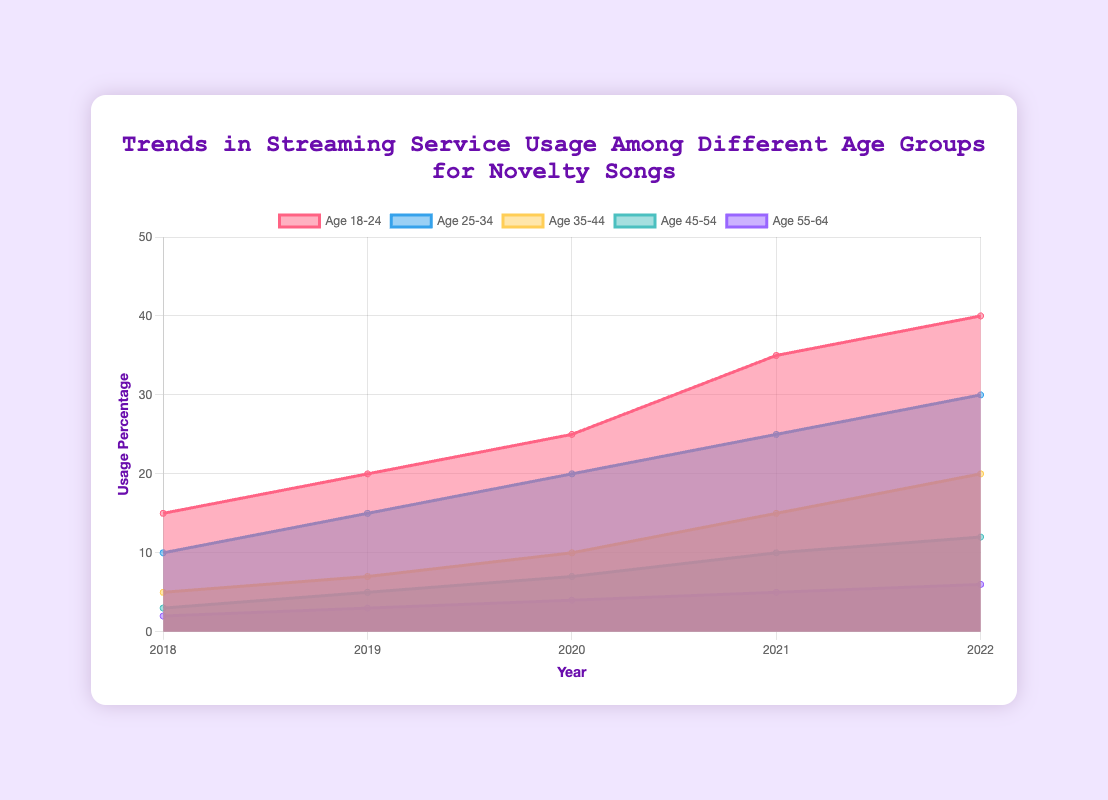Which age group shows the highest streaming service usage in 2022? By examining the data, we see that the Age 18-24 group has the highest value in 2022 at 40%.
Answer: Age 18-24 How has the streaming service usage percentage for the Age 25-34 group changed from 2018 to 2022? In 2018, the Age 25-34 group's usage was 10%. By 2022, it increased to 30%, so the change is 30% - 10% = 20%.
Answer: Increased by 20% What is the overall trend for the Age 45-54 group's streaming service usage over the years? The data shows an increasing trend from 3% in 2018 to 12% in 2022.
Answer: Increasing Which two age groups had the smallest and the largest usage growth from 2018 to 2022, respectively? The Age 18-24 group grew from 15% to 40%, whereas the Age 55-64 group grew from 2% to 6%. The largest growth is 40% - 15% = 25%, and the smallest is 6% - 2% = 4%.
Answer: Largest: Age 18-24, Smallest: Age 55-64 Compare the streaming service usage in 2020 between Age 18-24 and Age 35-44 groups. In 2020, Age 18-24 had 25%, and Age 35-44 had 10%. Therefore, Age 18-24 is higher by 25% - 10% = 15%.
Answer: Age 18-24 is 15% higher Across all age groups, what is the average streaming service usage in 2021? Summing the values for 2021: 35% (18-24) + 25% (25-34) + 15% (35-44) + 10% (45-54) + 5% (55-64) = 90%. Dividing by 5, we get an average of 90% / 5 = 18%.
Answer: 18% By how much did the streaming service usage for the Age 18-24 group increase from 2019 to 2021? From 2019's 20% to 2021's 35%, the increase is 35% - 20% = 15%.
Answer: 15% Is there any year where the Age 25-34 group's usage is higher than the Age 18-24 group's usage? For each year from 2018 to 2022, Age 18-24's usage is consistently higher than Age 25-34's usage.
Answer: No What year did the Age 35-44 group cross the 10% threshold in streaming service usage? The data shows that the Age 35-44 group crossed 10% usage in 2020 with a value of 10%.
Answer: 2020 